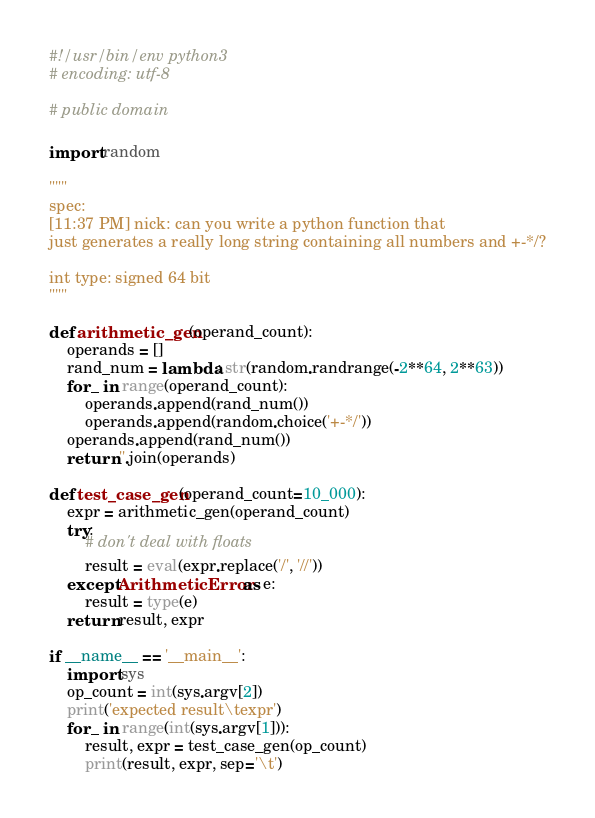Convert code to text. <code><loc_0><loc_0><loc_500><loc_500><_Python_>#!/usr/bin/env python3
# encoding: utf-8

# public domain

import random

"""
spec:
[11:37 PM] nick: can you write a python function that
just generates a really long string containing all numbers and +-*/?

int type: signed 64 bit
"""

def arithmetic_gen(operand_count):
	operands = []
	rand_num = lambda: str(random.randrange(-2**64, 2**63))
	for _ in range(operand_count):
		operands.append(rand_num())
		operands.append(random.choice('+-*/'))
	operands.append(rand_num())
	return ''.join(operands)

def test_case_gen(operand_count=10_000):
	expr = arithmetic_gen(operand_count)
	try:
		# don't deal with floats
		result = eval(expr.replace('/', '//'))
	except ArithmeticError as e:
		result = type(e)
	return result, expr

if __name__ == '__main__':
	import sys
	op_count = int(sys.argv[2])
	print('expected result\texpr')
	for _ in range(int(sys.argv[1])):
		result, expr = test_case_gen(op_count)
		print(result, expr, sep='\t')
</code> 